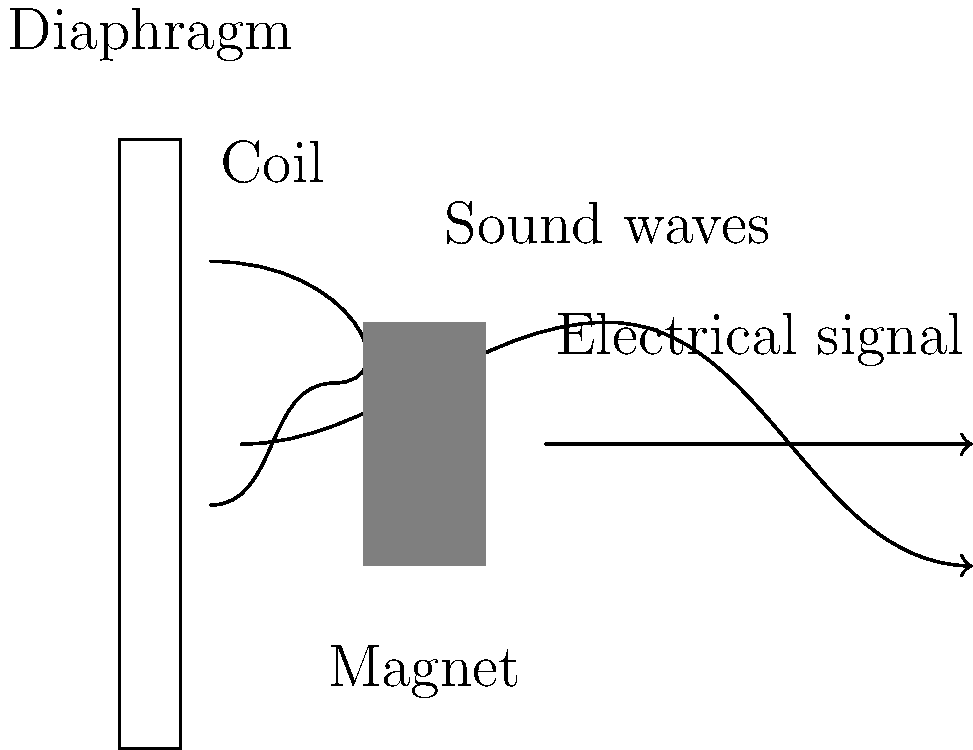As an upcoming independent artist who values well-engineered sound, you're interested in understanding the physics behind microphone technology. Explain how a dynamic microphone converts sound waves into electrical signals, focusing on the key physical principles involved in this process. The conversion of sound waves into electrical signals in a dynamic microphone involves several key physical principles:

1. Sound wave propagation: Sound waves are pressure variations that travel through the air.

2. Mechanical vibration: When sound waves reach the microphone's diaphragm, they cause it to vibrate. The diaphragm's movement corresponds to the frequency and amplitude of the incoming sound waves.

3. Faraday's law of electromagnetic induction: This law states that a changing magnetic field induces an electromotive force (EMF) in a conductor.

4. Magnetic field: A permanent magnet inside the microphone creates a static magnetic field.

5. Conductor in motion: A coil of wire (the conductor) is attached to the diaphragm and moves within the magnetic field as the diaphragm vibrates.

6. Induced current: As the coil moves through the magnetic field, it experiences a changing magnetic flux. According to Faraday's law, this changing flux induces an EMF in the coil.

7. Electrical signal generation: The induced EMF creates a small electrical current in the coil, which varies in proportion to the sound wave's characteristics.

8. Signal output: This varying electrical current is the electrical signal that represents the original sound wave.

The relationship between the induced EMF ($\varepsilon$) and the rate of change of magnetic flux ($\Phi_B$) is given by Faraday's law:

$$\varepsilon = -N\frac{d\Phi_B}{dt}$$

Where $N$ is the number of turns in the coil.

The magnitude of the induced EMF is proportional to the velocity of the coil's movement, which in turn is proportional to the amplitude of the sound waves. The frequency of the electrical signal matches the frequency of the sound waves.
Answer: Diaphragm vibrates with sound waves, moving attached coil through magnetic field, inducing EMF and current proportional to sound characteristics. 